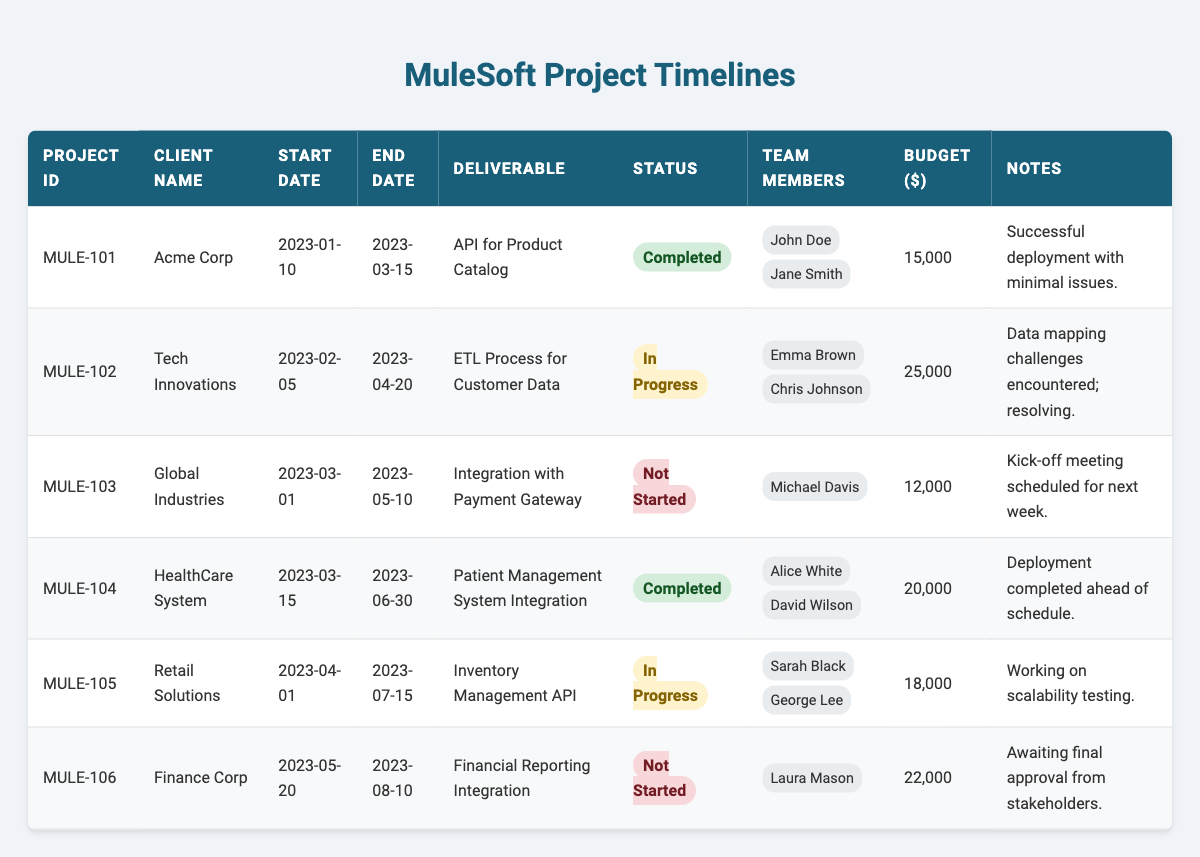What is the total budget for all projects? To find the total budget, I will add the budgets for each project: 15000 + 25000 + 12000 + 20000 + 18000 + 22000 = 112000.
Answer: 112000 How many projects have been completed? By reviewing the status of each project, I find that there are 2 projects marked as "Completed": MULE-101 and MULE-104.
Answer: 2 Which project has the highest budget? I will compare the budgets of all projects: MULE-102 has 25000, MULE-105 has 18000, MULE-101 has 15000, and MULE-106 has 22000. The highest budget is MULE-102 at 25000.
Answer: MULE-102 What is the duration of the project with ID MULE-103? The duration can be calculated by subtracting the Start Date (2023-03-01) from the End Date (2023-05-10): 2023-05-10 - 2023-03-01 = 2 months and 9 days.
Answer: 2 months and 9 days Are there any projects still in progress? I will check the statuses of each project and find that MULE-102 and MULE-105 are both listed as "In Progress".
Answer: Yes What is the average budget of the projects that are not started? The budgets for the projects that are not started are MULE-103 (12000) and MULE-106 (22000). The average is (12000 + 22000) / 2 = 17000.
Answer: 17000 Which team member is involved in the most projects? I will review the team members for each project: John Doe and Jane Smith for MULE-101, Emma Brown and Chris Johnson for MULE-102, Michael Davis for MULE-103, Alice White and David Wilson for MULE-104, Sarah Black and George Lee for MULE-105, and Laura Mason for MULE-106. Each one is listed only once, so no team member is involved in more than one project.
Answer: None What percentage of the total projects are completed? There are 6 total projects, and 2 of them are completed. The percentage is (2/6) * 100 = 33.33%.
Answer: 33.33% Which client's project has the earliest start date? Comparing the start dates, MULE-101 (Acme Corp) starts on 2023-01-10, which is earlier than all other projects.
Answer: Acme Corp How many different team members are involved across all projects? The team members listed are John Doe, Jane Smith, Emma Brown, Chris Johnson, Michael Davis, Alice White, David Wilson, Sarah Black, George Lee, and Laura Mason. There are 10 unique names.
Answer: 10 